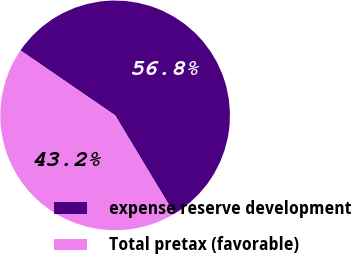Convert chart. <chart><loc_0><loc_0><loc_500><loc_500><pie_chart><fcel>expense reserve development<fcel>Total pretax (favorable)<nl><fcel>56.81%<fcel>43.19%<nl></chart> 